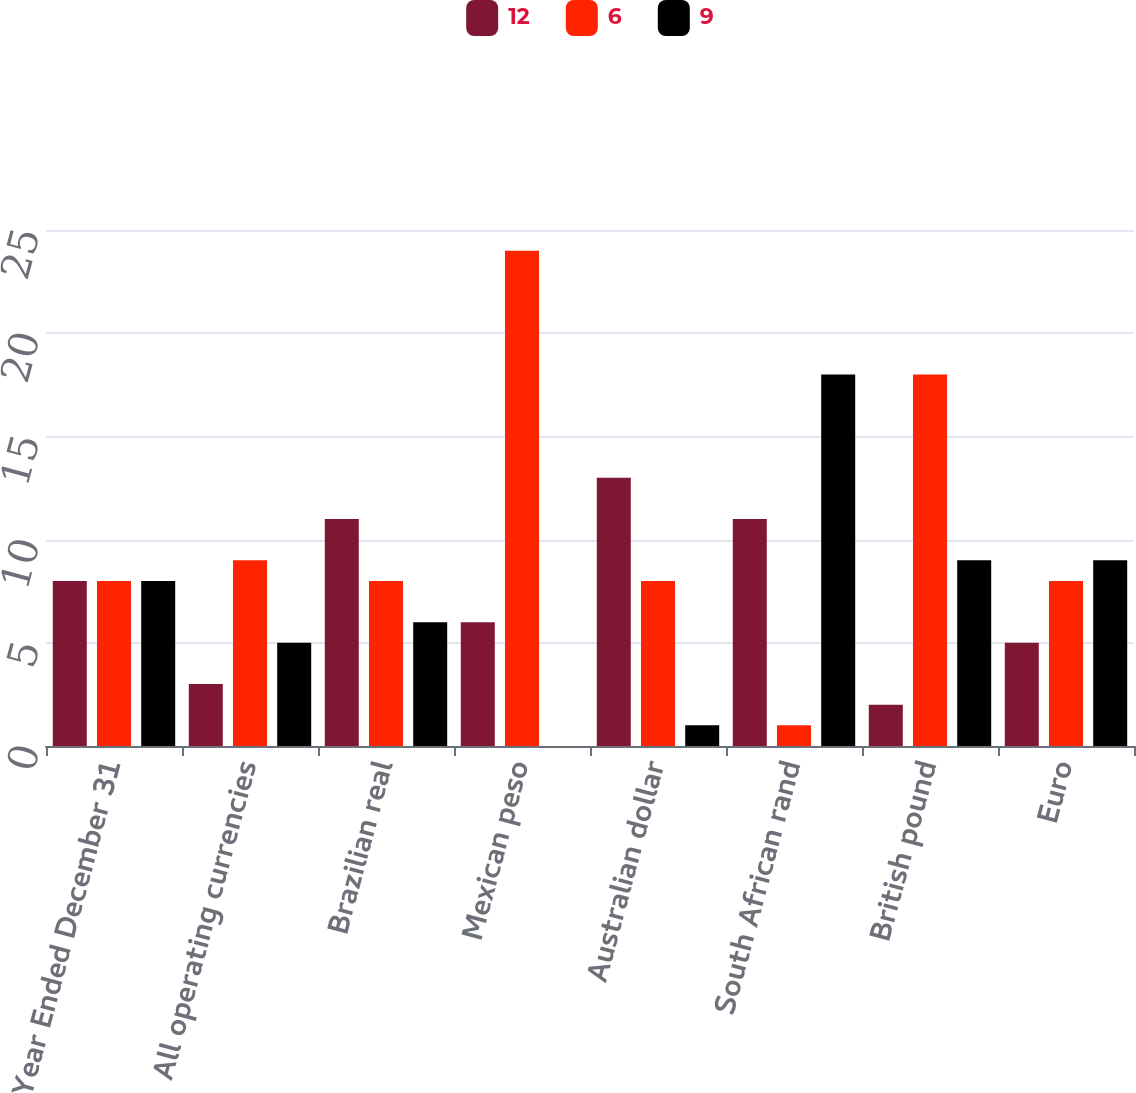Convert chart to OTSL. <chart><loc_0><loc_0><loc_500><loc_500><stacked_bar_chart><ecel><fcel>Year Ended December 31<fcel>All operating currencies<fcel>Brazilian real<fcel>Mexican peso<fcel>Australian dollar<fcel>South African rand<fcel>British pound<fcel>Euro<nl><fcel>12<fcel>8<fcel>3<fcel>11<fcel>6<fcel>13<fcel>11<fcel>2<fcel>5<nl><fcel>6<fcel>8<fcel>9<fcel>8<fcel>24<fcel>8<fcel>1<fcel>18<fcel>8<nl><fcel>9<fcel>8<fcel>5<fcel>6<fcel>0<fcel>1<fcel>18<fcel>9<fcel>9<nl></chart> 